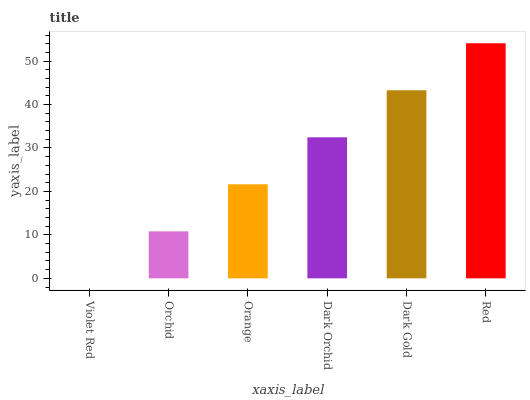Is Violet Red the minimum?
Answer yes or no. Yes. Is Red the maximum?
Answer yes or no. Yes. Is Orchid the minimum?
Answer yes or no. No. Is Orchid the maximum?
Answer yes or no. No. Is Orchid greater than Violet Red?
Answer yes or no. Yes. Is Violet Red less than Orchid?
Answer yes or no. Yes. Is Violet Red greater than Orchid?
Answer yes or no. No. Is Orchid less than Violet Red?
Answer yes or no. No. Is Dark Orchid the high median?
Answer yes or no. Yes. Is Orange the low median?
Answer yes or no. Yes. Is Orchid the high median?
Answer yes or no. No. Is Orchid the low median?
Answer yes or no. No. 